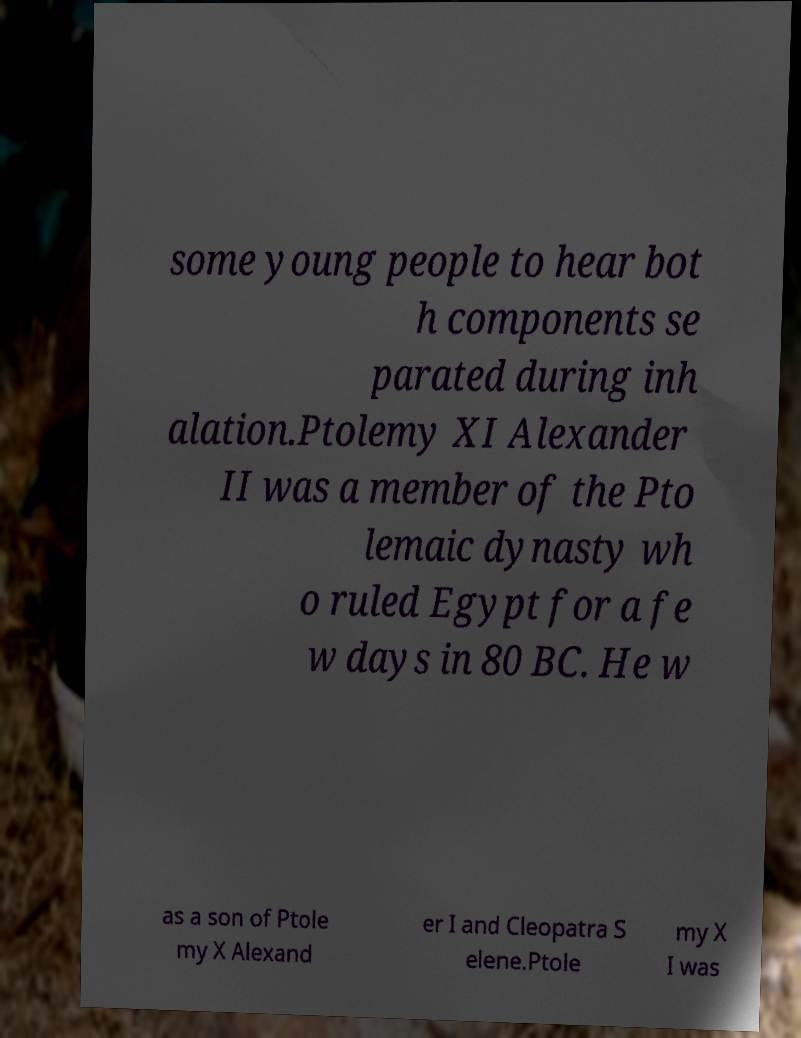Please read and relay the text visible in this image. What does it say? some young people to hear bot h components se parated during inh alation.Ptolemy XI Alexander II was a member of the Pto lemaic dynasty wh o ruled Egypt for a fe w days in 80 BC. He w as a son of Ptole my X Alexand er I and Cleopatra S elene.Ptole my X I was 